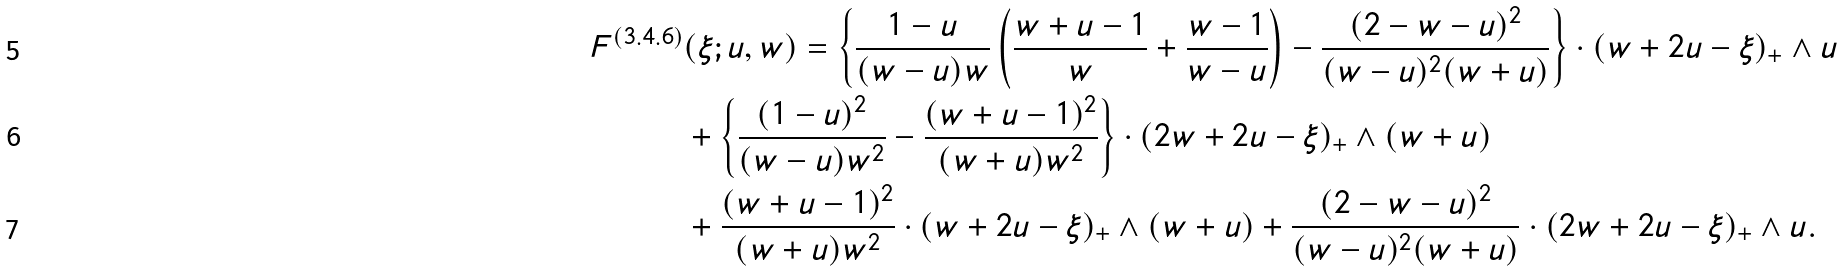Convert formula to latex. <formula><loc_0><loc_0><loc_500><loc_500>F ^ { ( 3 . 4 . 6 ) } & ( \xi ; u , w ) = \left \{ \frac { 1 - u } { ( w - u ) w } \left ( \frac { w + u - 1 } { w } + \frac { w - 1 } { w - u } \right ) - \frac { ( 2 - w - u ) ^ { 2 } } { ( w - u ) ^ { 2 } ( w + u ) } \right \} \cdot ( w + 2 u - \xi ) _ { + } \wedge u \\ & + \left \{ \frac { ( 1 - u ) ^ { 2 } } { ( w - u ) w ^ { 2 } } - \frac { ( w + u - 1 ) ^ { 2 } } { ( w + u ) w ^ { 2 } } \right \} \cdot ( 2 w + 2 u - \xi ) _ { + } \wedge ( w + u ) \\ & + \frac { ( w + u - 1 ) ^ { 2 } } { ( w + u ) w ^ { 2 } } \cdot ( w + 2 u - \xi ) _ { + } \wedge ( w + u ) + \frac { ( 2 - w - u ) ^ { 2 } } { ( w - u ) ^ { 2 } ( w + u ) } \cdot ( 2 w + 2 u - \xi ) _ { + } \wedge u .</formula> 